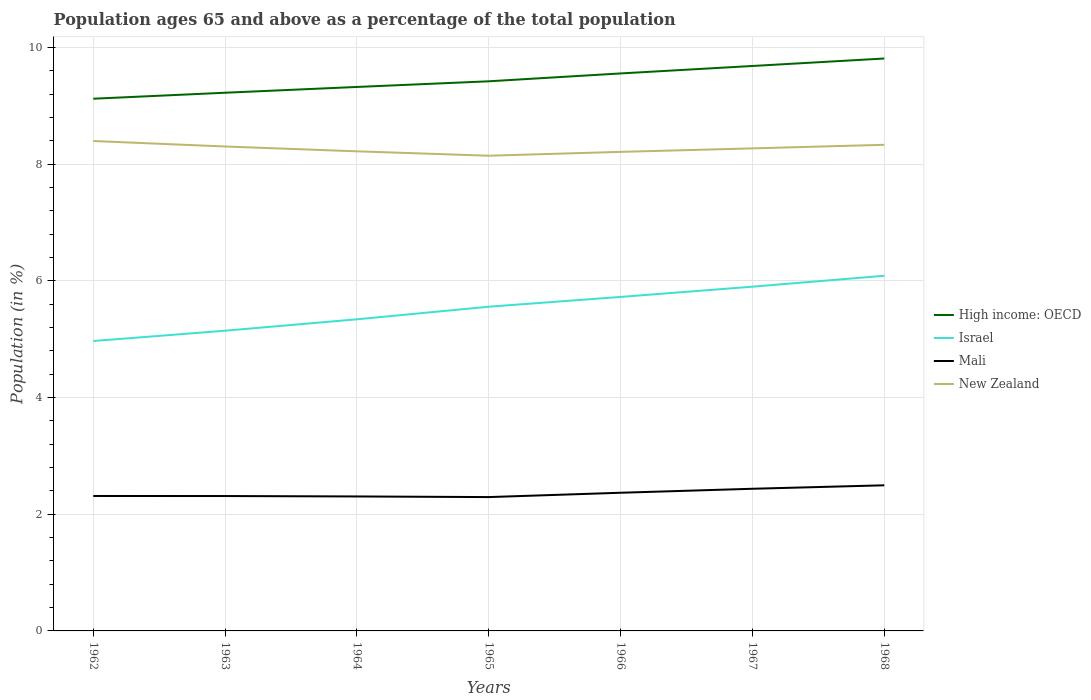Across all years, what is the maximum percentage of the population ages 65 and above in High income: OECD?
Make the answer very short. 9.12. In which year was the percentage of the population ages 65 and above in High income: OECD maximum?
Offer a very short reply. 1962. What is the total percentage of the population ages 65 and above in High income: OECD in the graph?
Keep it short and to the point. -0.36. What is the difference between the highest and the second highest percentage of the population ages 65 and above in Israel?
Your response must be concise. 1.12. Is the percentage of the population ages 65 and above in High income: OECD strictly greater than the percentage of the population ages 65 and above in New Zealand over the years?
Your answer should be very brief. No. How many lines are there?
Offer a very short reply. 4. How many years are there in the graph?
Ensure brevity in your answer.  7. How many legend labels are there?
Offer a very short reply. 4. How are the legend labels stacked?
Your answer should be compact. Vertical. What is the title of the graph?
Offer a very short reply. Population ages 65 and above as a percentage of the total population. Does "Albania" appear as one of the legend labels in the graph?
Your answer should be very brief. No. What is the Population (in %) in High income: OECD in 1962?
Your answer should be very brief. 9.12. What is the Population (in %) in Israel in 1962?
Offer a very short reply. 4.97. What is the Population (in %) of Mali in 1962?
Your answer should be very brief. 2.31. What is the Population (in %) in New Zealand in 1962?
Offer a terse response. 8.4. What is the Population (in %) in High income: OECD in 1963?
Your answer should be compact. 9.22. What is the Population (in %) of Israel in 1963?
Your answer should be compact. 5.14. What is the Population (in %) in Mali in 1963?
Keep it short and to the point. 2.31. What is the Population (in %) in New Zealand in 1963?
Your answer should be very brief. 8.3. What is the Population (in %) of High income: OECD in 1964?
Offer a terse response. 9.32. What is the Population (in %) in Israel in 1964?
Keep it short and to the point. 5.34. What is the Population (in %) of Mali in 1964?
Provide a succinct answer. 2.3. What is the Population (in %) in New Zealand in 1964?
Make the answer very short. 8.22. What is the Population (in %) in High income: OECD in 1965?
Provide a succinct answer. 9.42. What is the Population (in %) in Israel in 1965?
Your response must be concise. 5.56. What is the Population (in %) in Mali in 1965?
Keep it short and to the point. 2.29. What is the Population (in %) of New Zealand in 1965?
Ensure brevity in your answer.  8.14. What is the Population (in %) in High income: OECD in 1966?
Provide a short and direct response. 9.55. What is the Population (in %) in Israel in 1966?
Your answer should be very brief. 5.72. What is the Population (in %) in Mali in 1966?
Provide a succinct answer. 2.37. What is the Population (in %) of New Zealand in 1966?
Provide a succinct answer. 8.21. What is the Population (in %) in High income: OECD in 1967?
Your answer should be compact. 9.68. What is the Population (in %) in Israel in 1967?
Your answer should be very brief. 5.9. What is the Population (in %) of Mali in 1967?
Provide a short and direct response. 2.44. What is the Population (in %) of New Zealand in 1967?
Provide a succinct answer. 8.27. What is the Population (in %) of High income: OECD in 1968?
Give a very brief answer. 9.81. What is the Population (in %) in Israel in 1968?
Your answer should be very brief. 6.09. What is the Population (in %) in Mali in 1968?
Ensure brevity in your answer.  2.5. What is the Population (in %) in New Zealand in 1968?
Your answer should be very brief. 8.33. Across all years, what is the maximum Population (in %) of High income: OECD?
Your answer should be compact. 9.81. Across all years, what is the maximum Population (in %) of Israel?
Provide a short and direct response. 6.09. Across all years, what is the maximum Population (in %) of Mali?
Give a very brief answer. 2.5. Across all years, what is the maximum Population (in %) of New Zealand?
Ensure brevity in your answer.  8.4. Across all years, what is the minimum Population (in %) in High income: OECD?
Ensure brevity in your answer.  9.12. Across all years, what is the minimum Population (in %) of Israel?
Make the answer very short. 4.97. Across all years, what is the minimum Population (in %) in Mali?
Provide a short and direct response. 2.29. Across all years, what is the minimum Population (in %) of New Zealand?
Provide a short and direct response. 8.14. What is the total Population (in %) of High income: OECD in the graph?
Give a very brief answer. 66.13. What is the total Population (in %) in Israel in the graph?
Your answer should be very brief. 38.72. What is the total Population (in %) in Mali in the graph?
Provide a short and direct response. 16.52. What is the total Population (in %) in New Zealand in the graph?
Your answer should be compact. 57.87. What is the difference between the Population (in %) in High income: OECD in 1962 and that in 1963?
Your answer should be compact. -0.1. What is the difference between the Population (in %) of Israel in 1962 and that in 1963?
Keep it short and to the point. -0.18. What is the difference between the Population (in %) in Mali in 1962 and that in 1963?
Your answer should be compact. 0. What is the difference between the Population (in %) in New Zealand in 1962 and that in 1963?
Offer a terse response. 0.09. What is the difference between the Population (in %) in High income: OECD in 1962 and that in 1964?
Your answer should be very brief. -0.2. What is the difference between the Population (in %) in Israel in 1962 and that in 1964?
Your response must be concise. -0.37. What is the difference between the Population (in %) in Mali in 1962 and that in 1964?
Provide a succinct answer. 0.01. What is the difference between the Population (in %) in New Zealand in 1962 and that in 1964?
Your answer should be compact. 0.18. What is the difference between the Population (in %) in High income: OECD in 1962 and that in 1965?
Offer a terse response. -0.3. What is the difference between the Population (in %) of Israel in 1962 and that in 1965?
Ensure brevity in your answer.  -0.59. What is the difference between the Population (in %) in Mali in 1962 and that in 1965?
Provide a short and direct response. 0.02. What is the difference between the Population (in %) in New Zealand in 1962 and that in 1965?
Your answer should be compact. 0.25. What is the difference between the Population (in %) in High income: OECD in 1962 and that in 1966?
Make the answer very short. -0.43. What is the difference between the Population (in %) in Israel in 1962 and that in 1966?
Your answer should be very brief. -0.76. What is the difference between the Population (in %) of Mali in 1962 and that in 1966?
Your answer should be very brief. -0.06. What is the difference between the Population (in %) of New Zealand in 1962 and that in 1966?
Offer a very short reply. 0.19. What is the difference between the Population (in %) of High income: OECD in 1962 and that in 1967?
Ensure brevity in your answer.  -0.56. What is the difference between the Population (in %) in Israel in 1962 and that in 1967?
Your answer should be compact. -0.93. What is the difference between the Population (in %) in Mali in 1962 and that in 1967?
Provide a succinct answer. -0.12. What is the difference between the Population (in %) in New Zealand in 1962 and that in 1967?
Your answer should be compact. 0.13. What is the difference between the Population (in %) of High income: OECD in 1962 and that in 1968?
Provide a short and direct response. -0.69. What is the difference between the Population (in %) in Israel in 1962 and that in 1968?
Your answer should be compact. -1.12. What is the difference between the Population (in %) in Mali in 1962 and that in 1968?
Offer a very short reply. -0.18. What is the difference between the Population (in %) in New Zealand in 1962 and that in 1968?
Keep it short and to the point. 0.06. What is the difference between the Population (in %) of High income: OECD in 1963 and that in 1964?
Provide a short and direct response. -0.1. What is the difference between the Population (in %) of Israel in 1963 and that in 1964?
Ensure brevity in your answer.  -0.2. What is the difference between the Population (in %) of Mali in 1963 and that in 1964?
Your answer should be compact. 0.01. What is the difference between the Population (in %) in New Zealand in 1963 and that in 1964?
Your response must be concise. 0.08. What is the difference between the Population (in %) in High income: OECD in 1963 and that in 1965?
Your answer should be compact. -0.2. What is the difference between the Population (in %) of Israel in 1963 and that in 1965?
Your answer should be compact. -0.41. What is the difference between the Population (in %) in Mali in 1963 and that in 1965?
Make the answer very short. 0.02. What is the difference between the Population (in %) of New Zealand in 1963 and that in 1965?
Give a very brief answer. 0.16. What is the difference between the Population (in %) of High income: OECD in 1963 and that in 1966?
Your response must be concise. -0.33. What is the difference between the Population (in %) in Israel in 1963 and that in 1966?
Your answer should be compact. -0.58. What is the difference between the Population (in %) of Mali in 1963 and that in 1966?
Give a very brief answer. -0.06. What is the difference between the Population (in %) in New Zealand in 1963 and that in 1966?
Offer a terse response. 0.09. What is the difference between the Population (in %) of High income: OECD in 1963 and that in 1967?
Your answer should be very brief. -0.46. What is the difference between the Population (in %) in Israel in 1963 and that in 1967?
Your response must be concise. -0.75. What is the difference between the Population (in %) of Mali in 1963 and that in 1967?
Offer a very short reply. -0.12. What is the difference between the Population (in %) in New Zealand in 1963 and that in 1967?
Make the answer very short. 0.03. What is the difference between the Population (in %) in High income: OECD in 1963 and that in 1968?
Make the answer very short. -0.59. What is the difference between the Population (in %) of Israel in 1963 and that in 1968?
Make the answer very short. -0.94. What is the difference between the Population (in %) of Mali in 1963 and that in 1968?
Your response must be concise. -0.18. What is the difference between the Population (in %) in New Zealand in 1963 and that in 1968?
Your answer should be compact. -0.03. What is the difference between the Population (in %) of High income: OECD in 1964 and that in 1965?
Provide a succinct answer. -0.1. What is the difference between the Population (in %) of Israel in 1964 and that in 1965?
Keep it short and to the point. -0.22. What is the difference between the Population (in %) of Mali in 1964 and that in 1965?
Offer a terse response. 0.01. What is the difference between the Population (in %) in New Zealand in 1964 and that in 1965?
Your answer should be compact. 0.08. What is the difference between the Population (in %) of High income: OECD in 1964 and that in 1966?
Give a very brief answer. -0.23. What is the difference between the Population (in %) of Israel in 1964 and that in 1966?
Offer a very short reply. -0.38. What is the difference between the Population (in %) in Mali in 1964 and that in 1966?
Provide a succinct answer. -0.06. What is the difference between the Population (in %) of New Zealand in 1964 and that in 1966?
Your answer should be compact. 0.01. What is the difference between the Population (in %) in High income: OECD in 1964 and that in 1967?
Provide a short and direct response. -0.36. What is the difference between the Population (in %) of Israel in 1964 and that in 1967?
Offer a very short reply. -0.56. What is the difference between the Population (in %) in Mali in 1964 and that in 1967?
Ensure brevity in your answer.  -0.13. What is the difference between the Population (in %) in New Zealand in 1964 and that in 1967?
Make the answer very short. -0.05. What is the difference between the Population (in %) in High income: OECD in 1964 and that in 1968?
Ensure brevity in your answer.  -0.49. What is the difference between the Population (in %) in Israel in 1964 and that in 1968?
Your answer should be very brief. -0.75. What is the difference between the Population (in %) in Mali in 1964 and that in 1968?
Provide a succinct answer. -0.19. What is the difference between the Population (in %) of New Zealand in 1964 and that in 1968?
Offer a terse response. -0.11. What is the difference between the Population (in %) of High income: OECD in 1965 and that in 1966?
Your response must be concise. -0.13. What is the difference between the Population (in %) of Israel in 1965 and that in 1966?
Make the answer very short. -0.17. What is the difference between the Population (in %) in Mali in 1965 and that in 1966?
Provide a short and direct response. -0.07. What is the difference between the Population (in %) in New Zealand in 1965 and that in 1966?
Give a very brief answer. -0.07. What is the difference between the Population (in %) in High income: OECD in 1965 and that in 1967?
Provide a succinct answer. -0.26. What is the difference between the Population (in %) of Israel in 1965 and that in 1967?
Your answer should be very brief. -0.34. What is the difference between the Population (in %) of Mali in 1965 and that in 1967?
Your answer should be compact. -0.14. What is the difference between the Population (in %) of New Zealand in 1965 and that in 1967?
Your response must be concise. -0.13. What is the difference between the Population (in %) in High income: OECD in 1965 and that in 1968?
Your response must be concise. -0.39. What is the difference between the Population (in %) of Israel in 1965 and that in 1968?
Keep it short and to the point. -0.53. What is the difference between the Population (in %) of Mali in 1965 and that in 1968?
Your response must be concise. -0.2. What is the difference between the Population (in %) in New Zealand in 1965 and that in 1968?
Your answer should be compact. -0.19. What is the difference between the Population (in %) in High income: OECD in 1966 and that in 1967?
Your response must be concise. -0.13. What is the difference between the Population (in %) of Israel in 1966 and that in 1967?
Ensure brevity in your answer.  -0.18. What is the difference between the Population (in %) in Mali in 1966 and that in 1967?
Your response must be concise. -0.07. What is the difference between the Population (in %) in New Zealand in 1966 and that in 1967?
Ensure brevity in your answer.  -0.06. What is the difference between the Population (in %) of High income: OECD in 1966 and that in 1968?
Your answer should be compact. -0.26. What is the difference between the Population (in %) in Israel in 1966 and that in 1968?
Give a very brief answer. -0.36. What is the difference between the Population (in %) of Mali in 1966 and that in 1968?
Your response must be concise. -0.13. What is the difference between the Population (in %) of New Zealand in 1966 and that in 1968?
Your response must be concise. -0.12. What is the difference between the Population (in %) in High income: OECD in 1967 and that in 1968?
Your answer should be compact. -0.13. What is the difference between the Population (in %) of Israel in 1967 and that in 1968?
Keep it short and to the point. -0.19. What is the difference between the Population (in %) in Mali in 1967 and that in 1968?
Keep it short and to the point. -0.06. What is the difference between the Population (in %) in New Zealand in 1967 and that in 1968?
Your answer should be very brief. -0.06. What is the difference between the Population (in %) of High income: OECD in 1962 and the Population (in %) of Israel in 1963?
Your answer should be very brief. 3.98. What is the difference between the Population (in %) of High income: OECD in 1962 and the Population (in %) of Mali in 1963?
Make the answer very short. 6.81. What is the difference between the Population (in %) of High income: OECD in 1962 and the Population (in %) of New Zealand in 1963?
Provide a succinct answer. 0.82. What is the difference between the Population (in %) of Israel in 1962 and the Population (in %) of Mali in 1963?
Offer a terse response. 2.66. What is the difference between the Population (in %) of Israel in 1962 and the Population (in %) of New Zealand in 1963?
Provide a short and direct response. -3.33. What is the difference between the Population (in %) in Mali in 1962 and the Population (in %) in New Zealand in 1963?
Give a very brief answer. -5.99. What is the difference between the Population (in %) of High income: OECD in 1962 and the Population (in %) of Israel in 1964?
Your response must be concise. 3.78. What is the difference between the Population (in %) of High income: OECD in 1962 and the Population (in %) of Mali in 1964?
Offer a very short reply. 6.82. What is the difference between the Population (in %) of High income: OECD in 1962 and the Population (in %) of New Zealand in 1964?
Provide a short and direct response. 0.9. What is the difference between the Population (in %) of Israel in 1962 and the Population (in %) of Mali in 1964?
Give a very brief answer. 2.66. What is the difference between the Population (in %) of Israel in 1962 and the Population (in %) of New Zealand in 1964?
Provide a short and direct response. -3.25. What is the difference between the Population (in %) in Mali in 1962 and the Population (in %) in New Zealand in 1964?
Offer a terse response. -5.91. What is the difference between the Population (in %) of High income: OECD in 1962 and the Population (in %) of Israel in 1965?
Keep it short and to the point. 3.56. What is the difference between the Population (in %) of High income: OECD in 1962 and the Population (in %) of Mali in 1965?
Offer a terse response. 6.83. What is the difference between the Population (in %) in High income: OECD in 1962 and the Population (in %) in New Zealand in 1965?
Your response must be concise. 0.98. What is the difference between the Population (in %) of Israel in 1962 and the Population (in %) of Mali in 1965?
Provide a short and direct response. 2.67. What is the difference between the Population (in %) in Israel in 1962 and the Population (in %) in New Zealand in 1965?
Offer a very short reply. -3.18. What is the difference between the Population (in %) in Mali in 1962 and the Population (in %) in New Zealand in 1965?
Your answer should be compact. -5.83. What is the difference between the Population (in %) in High income: OECD in 1962 and the Population (in %) in Israel in 1966?
Provide a short and direct response. 3.4. What is the difference between the Population (in %) in High income: OECD in 1962 and the Population (in %) in Mali in 1966?
Your answer should be compact. 6.75. What is the difference between the Population (in %) of High income: OECD in 1962 and the Population (in %) of New Zealand in 1966?
Provide a succinct answer. 0.91. What is the difference between the Population (in %) of Israel in 1962 and the Population (in %) of Mali in 1966?
Provide a short and direct response. 2.6. What is the difference between the Population (in %) of Israel in 1962 and the Population (in %) of New Zealand in 1966?
Keep it short and to the point. -3.24. What is the difference between the Population (in %) in Mali in 1962 and the Population (in %) in New Zealand in 1966?
Provide a succinct answer. -5.9. What is the difference between the Population (in %) of High income: OECD in 1962 and the Population (in %) of Israel in 1967?
Provide a succinct answer. 3.22. What is the difference between the Population (in %) in High income: OECD in 1962 and the Population (in %) in Mali in 1967?
Offer a very short reply. 6.68. What is the difference between the Population (in %) in High income: OECD in 1962 and the Population (in %) in New Zealand in 1967?
Give a very brief answer. 0.85. What is the difference between the Population (in %) of Israel in 1962 and the Population (in %) of Mali in 1967?
Your answer should be compact. 2.53. What is the difference between the Population (in %) in Israel in 1962 and the Population (in %) in New Zealand in 1967?
Offer a terse response. -3.3. What is the difference between the Population (in %) of Mali in 1962 and the Population (in %) of New Zealand in 1967?
Keep it short and to the point. -5.96. What is the difference between the Population (in %) of High income: OECD in 1962 and the Population (in %) of Israel in 1968?
Keep it short and to the point. 3.03. What is the difference between the Population (in %) in High income: OECD in 1962 and the Population (in %) in Mali in 1968?
Your answer should be compact. 6.62. What is the difference between the Population (in %) of High income: OECD in 1962 and the Population (in %) of New Zealand in 1968?
Offer a very short reply. 0.79. What is the difference between the Population (in %) of Israel in 1962 and the Population (in %) of Mali in 1968?
Your response must be concise. 2.47. What is the difference between the Population (in %) in Israel in 1962 and the Population (in %) in New Zealand in 1968?
Offer a very short reply. -3.36. What is the difference between the Population (in %) in Mali in 1962 and the Population (in %) in New Zealand in 1968?
Make the answer very short. -6.02. What is the difference between the Population (in %) of High income: OECD in 1963 and the Population (in %) of Israel in 1964?
Make the answer very short. 3.88. What is the difference between the Population (in %) in High income: OECD in 1963 and the Population (in %) in Mali in 1964?
Your answer should be compact. 6.92. What is the difference between the Population (in %) in High income: OECD in 1963 and the Population (in %) in New Zealand in 1964?
Keep it short and to the point. 1. What is the difference between the Population (in %) in Israel in 1963 and the Population (in %) in Mali in 1964?
Keep it short and to the point. 2.84. What is the difference between the Population (in %) in Israel in 1963 and the Population (in %) in New Zealand in 1964?
Your answer should be very brief. -3.07. What is the difference between the Population (in %) of Mali in 1963 and the Population (in %) of New Zealand in 1964?
Keep it short and to the point. -5.91. What is the difference between the Population (in %) in High income: OECD in 1963 and the Population (in %) in Israel in 1965?
Offer a terse response. 3.67. What is the difference between the Population (in %) of High income: OECD in 1963 and the Population (in %) of Mali in 1965?
Your answer should be compact. 6.93. What is the difference between the Population (in %) in High income: OECD in 1963 and the Population (in %) in New Zealand in 1965?
Give a very brief answer. 1.08. What is the difference between the Population (in %) of Israel in 1963 and the Population (in %) of Mali in 1965?
Make the answer very short. 2.85. What is the difference between the Population (in %) in Israel in 1963 and the Population (in %) in New Zealand in 1965?
Your answer should be compact. -3. What is the difference between the Population (in %) of Mali in 1963 and the Population (in %) of New Zealand in 1965?
Ensure brevity in your answer.  -5.83. What is the difference between the Population (in %) of High income: OECD in 1963 and the Population (in %) of Israel in 1966?
Your answer should be compact. 3.5. What is the difference between the Population (in %) in High income: OECD in 1963 and the Population (in %) in Mali in 1966?
Provide a short and direct response. 6.85. What is the difference between the Population (in %) of High income: OECD in 1963 and the Population (in %) of New Zealand in 1966?
Offer a very short reply. 1.01. What is the difference between the Population (in %) of Israel in 1963 and the Population (in %) of Mali in 1966?
Provide a short and direct response. 2.78. What is the difference between the Population (in %) in Israel in 1963 and the Population (in %) in New Zealand in 1966?
Your response must be concise. -3.06. What is the difference between the Population (in %) in Mali in 1963 and the Population (in %) in New Zealand in 1966?
Your answer should be compact. -5.9. What is the difference between the Population (in %) in High income: OECD in 1963 and the Population (in %) in Israel in 1967?
Provide a succinct answer. 3.32. What is the difference between the Population (in %) in High income: OECD in 1963 and the Population (in %) in Mali in 1967?
Provide a short and direct response. 6.79. What is the difference between the Population (in %) in High income: OECD in 1963 and the Population (in %) in New Zealand in 1967?
Make the answer very short. 0.95. What is the difference between the Population (in %) of Israel in 1963 and the Population (in %) of Mali in 1967?
Provide a succinct answer. 2.71. What is the difference between the Population (in %) in Israel in 1963 and the Population (in %) in New Zealand in 1967?
Ensure brevity in your answer.  -3.12. What is the difference between the Population (in %) of Mali in 1963 and the Population (in %) of New Zealand in 1967?
Keep it short and to the point. -5.96. What is the difference between the Population (in %) of High income: OECD in 1963 and the Population (in %) of Israel in 1968?
Ensure brevity in your answer.  3.14. What is the difference between the Population (in %) of High income: OECD in 1963 and the Population (in %) of Mali in 1968?
Provide a succinct answer. 6.73. What is the difference between the Population (in %) in High income: OECD in 1963 and the Population (in %) in New Zealand in 1968?
Provide a short and direct response. 0.89. What is the difference between the Population (in %) in Israel in 1963 and the Population (in %) in Mali in 1968?
Ensure brevity in your answer.  2.65. What is the difference between the Population (in %) in Israel in 1963 and the Population (in %) in New Zealand in 1968?
Offer a terse response. -3.19. What is the difference between the Population (in %) in Mali in 1963 and the Population (in %) in New Zealand in 1968?
Your response must be concise. -6.02. What is the difference between the Population (in %) of High income: OECD in 1964 and the Population (in %) of Israel in 1965?
Your answer should be very brief. 3.77. What is the difference between the Population (in %) of High income: OECD in 1964 and the Population (in %) of Mali in 1965?
Offer a very short reply. 7.03. What is the difference between the Population (in %) in High income: OECD in 1964 and the Population (in %) in New Zealand in 1965?
Give a very brief answer. 1.18. What is the difference between the Population (in %) in Israel in 1964 and the Population (in %) in Mali in 1965?
Your answer should be very brief. 3.05. What is the difference between the Population (in %) of Israel in 1964 and the Population (in %) of New Zealand in 1965?
Provide a succinct answer. -2.8. What is the difference between the Population (in %) of Mali in 1964 and the Population (in %) of New Zealand in 1965?
Keep it short and to the point. -5.84. What is the difference between the Population (in %) of High income: OECD in 1964 and the Population (in %) of Israel in 1966?
Make the answer very short. 3.6. What is the difference between the Population (in %) in High income: OECD in 1964 and the Population (in %) in Mali in 1966?
Provide a succinct answer. 6.95. What is the difference between the Population (in %) of High income: OECD in 1964 and the Population (in %) of New Zealand in 1966?
Keep it short and to the point. 1.11. What is the difference between the Population (in %) in Israel in 1964 and the Population (in %) in Mali in 1966?
Your answer should be compact. 2.97. What is the difference between the Population (in %) in Israel in 1964 and the Population (in %) in New Zealand in 1966?
Your response must be concise. -2.87. What is the difference between the Population (in %) in Mali in 1964 and the Population (in %) in New Zealand in 1966?
Provide a succinct answer. -5.9. What is the difference between the Population (in %) of High income: OECD in 1964 and the Population (in %) of Israel in 1967?
Your response must be concise. 3.42. What is the difference between the Population (in %) in High income: OECD in 1964 and the Population (in %) in Mali in 1967?
Keep it short and to the point. 6.89. What is the difference between the Population (in %) in High income: OECD in 1964 and the Population (in %) in New Zealand in 1967?
Offer a very short reply. 1.05. What is the difference between the Population (in %) of Israel in 1964 and the Population (in %) of Mali in 1967?
Offer a terse response. 2.9. What is the difference between the Population (in %) of Israel in 1964 and the Population (in %) of New Zealand in 1967?
Make the answer very short. -2.93. What is the difference between the Population (in %) of Mali in 1964 and the Population (in %) of New Zealand in 1967?
Offer a very short reply. -5.96. What is the difference between the Population (in %) in High income: OECD in 1964 and the Population (in %) in Israel in 1968?
Offer a terse response. 3.24. What is the difference between the Population (in %) in High income: OECD in 1964 and the Population (in %) in Mali in 1968?
Keep it short and to the point. 6.83. What is the difference between the Population (in %) in High income: OECD in 1964 and the Population (in %) in New Zealand in 1968?
Make the answer very short. 0.99. What is the difference between the Population (in %) of Israel in 1964 and the Population (in %) of Mali in 1968?
Offer a very short reply. 2.84. What is the difference between the Population (in %) in Israel in 1964 and the Population (in %) in New Zealand in 1968?
Make the answer very short. -2.99. What is the difference between the Population (in %) of Mali in 1964 and the Population (in %) of New Zealand in 1968?
Your response must be concise. -6.03. What is the difference between the Population (in %) of High income: OECD in 1965 and the Population (in %) of Israel in 1966?
Your answer should be compact. 3.69. What is the difference between the Population (in %) in High income: OECD in 1965 and the Population (in %) in Mali in 1966?
Keep it short and to the point. 7.05. What is the difference between the Population (in %) of High income: OECD in 1965 and the Population (in %) of New Zealand in 1966?
Ensure brevity in your answer.  1.21. What is the difference between the Population (in %) in Israel in 1965 and the Population (in %) in Mali in 1966?
Offer a terse response. 3.19. What is the difference between the Population (in %) of Israel in 1965 and the Population (in %) of New Zealand in 1966?
Provide a short and direct response. -2.65. What is the difference between the Population (in %) of Mali in 1965 and the Population (in %) of New Zealand in 1966?
Offer a terse response. -5.92. What is the difference between the Population (in %) of High income: OECD in 1965 and the Population (in %) of Israel in 1967?
Offer a very short reply. 3.52. What is the difference between the Population (in %) in High income: OECD in 1965 and the Population (in %) in Mali in 1967?
Your answer should be compact. 6.98. What is the difference between the Population (in %) in High income: OECD in 1965 and the Population (in %) in New Zealand in 1967?
Your response must be concise. 1.15. What is the difference between the Population (in %) of Israel in 1965 and the Population (in %) of Mali in 1967?
Provide a succinct answer. 3.12. What is the difference between the Population (in %) in Israel in 1965 and the Population (in %) in New Zealand in 1967?
Offer a very short reply. -2.71. What is the difference between the Population (in %) of Mali in 1965 and the Population (in %) of New Zealand in 1967?
Your answer should be very brief. -5.98. What is the difference between the Population (in %) of High income: OECD in 1965 and the Population (in %) of Israel in 1968?
Make the answer very short. 3.33. What is the difference between the Population (in %) of High income: OECD in 1965 and the Population (in %) of Mali in 1968?
Offer a very short reply. 6.92. What is the difference between the Population (in %) in High income: OECD in 1965 and the Population (in %) in New Zealand in 1968?
Provide a short and direct response. 1.09. What is the difference between the Population (in %) in Israel in 1965 and the Population (in %) in Mali in 1968?
Provide a succinct answer. 3.06. What is the difference between the Population (in %) of Israel in 1965 and the Population (in %) of New Zealand in 1968?
Keep it short and to the point. -2.77. What is the difference between the Population (in %) of Mali in 1965 and the Population (in %) of New Zealand in 1968?
Your answer should be compact. -6.04. What is the difference between the Population (in %) in High income: OECD in 1966 and the Population (in %) in Israel in 1967?
Provide a short and direct response. 3.65. What is the difference between the Population (in %) of High income: OECD in 1966 and the Population (in %) of Mali in 1967?
Provide a succinct answer. 7.12. What is the difference between the Population (in %) of High income: OECD in 1966 and the Population (in %) of New Zealand in 1967?
Offer a very short reply. 1.28. What is the difference between the Population (in %) in Israel in 1966 and the Population (in %) in Mali in 1967?
Offer a very short reply. 3.29. What is the difference between the Population (in %) of Israel in 1966 and the Population (in %) of New Zealand in 1967?
Your answer should be very brief. -2.55. What is the difference between the Population (in %) in Mali in 1966 and the Population (in %) in New Zealand in 1967?
Your answer should be very brief. -5.9. What is the difference between the Population (in %) of High income: OECD in 1966 and the Population (in %) of Israel in 1968?
Give a very brief answer. 3.47. What is the difference between the Population (in %) in High income: OECD in 1966 and the Population (in %) in Mali in 1968?
Ensure brevity in your answer.  7.06. What is the difference between the Population (in %) of High income: OECD in 1966 and the Population (in %) of New Zealand in 1968?
Your answer should be compact. 1.22. What is the difference between the Population (in %) in Israel in 1966 and the Population (in %) in Mali in 1968?
Keep it short and to the point. 3.23. What is the difference between the Population (in %) of Israel in 1966 and the Population (in %) of New Zealand in 1968?
Provide a succinct answer. -2.61. What is the difference between the Population (in %) in Mali in 1966 and the Population (in %) in New Zealand in 1968?
Offer a very short reply. -5.96. What is the difference between the Population (in %) of High income: OECD in 1967 and the Population (in %) of Israel in 1968?
Ensure brevity in your answer.  3.6. What is the difference between the Population (in %) of High income: OECD in 1967 and the Population (in %) of Mali in 1968?
Provide a short and direct response. 7.19. What is the difference between the Population (in %) of High income: OECD in 1967 and the Population (in %) of New Zealand in 1968?
Make the answer very short. 1.35. What is the difference between the Population (in %) in Israel in 1967 and the Population (in %) in Mali in 1968?
Give a very brief answer. 3.4. What is the difference between the Population (in %) of Israel in 1967 and the Population (in %) of New Zealand in 1968?
Give a very brief answer. -2.43. What is the difference between the Population (in %) in Mali in 1967 and the Population (in %) in New Zealand in 1968?
Provide a succinct answer. -5.89. What is the average Population (in %) of High income: OECD per year?
Provide a succinct answer. 9.45. What is the average Population (in %) in Israel per year?
Offer a very short reply. 5.53. What is the average Population (in %) in Mali per year?
Provide a short and direct response. 2.36. What is the average Population (in %) in New Zealand per year?
Provide a short and direct response. 8.27. In the year 1962, what is the difference between the Population (in %) in High income: OECD and Population (in %) in Israel?
Ensure brevity in your answer.  4.15. In the year 1962, what is the difference between the Population (in %) in High income: OECD and Population (in %) in Mali?
Ensure brevity in your answer.  6.81. In the year 1962, what is the difference between the Population (in %) in High income: OECD and Population (in %) in New Zealand?
Your answer should be very brief. 0.72. In the year 1962, what is the difference between the Population (in %) in Israel and Population (in %) in Mali?
Give a very brief answer. 2.66. In the year 1962, what is the difference between the Population (in %) in Israel and Population (in %) in New Zealand?
Give a very brief answer. -3.43. In the year 1962, what is the difference between the Population (in %) of Mali and Population (in %) of New Zealand?
Ensure brevity in your answer.  -6.08. In the year 1963, what is the difference between the Population (in %) in High income: OECD and Population (in %) in Israel?
Your answer should be compact. 4.08. In the year 1963, what is the difference between the Population (in %) of High income: OECD and Population (in %) of Mali?
Provide a succinct answer. 6.91. In the year 1963, what is the difference between the Population (in %) in High income: OECD and Population (in %) in New Zealand?
Offer a terse response. 0.92. In the year 1963, what is the difference between the Population (in %) in Israel and Population (in %) in Mali?
Make the answer very short. 2.83. In the year 1963, what is the difference between the Population (in %) of Israel and Population (in %) of New Zealand?
Give a very brief answer. -3.16. In the year 1963, what is the difference between the Population (in %) in Mali and Population (in %) in New Zealand?
Keep it short and to the point. -5.99. In the year 1964, what is the difference between the Population (in %) in High income: OECD and Population (in %) in Israel?
Your answer should be compact. 3.98. In the year 1964, what is the difference between the Population (in %) of High income: OECD and Population (in %) of Mali?
Offer a terse response. 7.02. In the year 1964, what is the difference between the Population (in %) in High income: OECD and Population (in %) in New Zealand?
Give a very brief answer. 1.1. In the year 1964, what is the difference between the Population (in %) in Israel and Population (in %) in Mali?
Offer a terse response. 3.04. In the year 1964, what is the difference between the Population (in %) of Israel and Population (in %) of New Zealand?
Make the answer very short. -2.88. In the year 1964, what is the difference between the Population (in %) in Mali and Population (in %) in New Zealand?
Your answer should be compact. -5.91. In the year 1965, what is the difference between the Population (in %) in High income: OECD and Population (in %) in Israel?
Offer a terse response. 3.86. In the year 1965, what is the difference between the Population (in %) of High income: OECD and Population (in %) of Mali?
Your response must be concise. 7.12. In the year 1965, what is the difference between the Population (in %) of High income: OECD and Population (in %) of New Zealand?
Give a very brief answer. 1.28. In the year 1965, what is the difference between the Population (in %) in Israel and Population (in %) in Mali?
Your answer should be compact. 3.26. In the year 1965, what is the difference between the Population (in %) in Israel and Population (in %) in New Zealand?
Provide a short and direct response. -2.59. In the year 1965, what is the difference between the Population (in %) in Mali and Population (in %) in New Zealand?
Ensure brevity in your answer.  -5.85. In the year 1966, what is the difference between the Population (in %) in High income: OECD and Population (in %) in Israel?
Offer a terse response. 3.83. In the year 1966, what is the difference between the Population (in %) in High income: OECD and Population (in %) in Mali?
Ensure brevity in your answer.  7.19. In the year 1966, what is the difference between the Population (in %) of High income: OECD and Population (in %) of New Zealand?
Your response must be concise. 1.34. In the year 1966, what is the difference between the Population (in %) in Israel and Population (in %) in Mali?
Your answer should be compact. 3.36. In the year 1966, what is the difference between the Population (in %) of Israel and Population (in %) of New Zealand?
Provide a short and direct response. -2.49. In the year 1966, what is the difference between the Population (in %) in Mali and Population (in %) in New Zealand?
Give a very brief answer. -5.84. In the year 1967, what is the difference between the Population (in %) in High income: OECD and Population (in %) in Israel?
Your answer should be compact. 3.78. In the year 1967, what is the difference between the Population (in %) of High income: OECD and Population (in %) of Mali?
Your answer should be very brief. 7.25. In the year 1967, what is the difference between the Population (in %) in High income: OECD and Population (in %) in New Zealand?
Ensure brevity in your answer.  1.41. In the year 1967, what is the difference between the Population (in %) in Israel and Population (in %) in Mali?
Offer a very short reply. 3.46. In the year 1967, what is the difference between the Population (in %) in Israel and Population (in %) in New Zealand?
Your response must be concise. -2.37. In the year 1967, what is the difference between the Population (in %) of Mali and Population (in %) of New Zealand?
Give a very brief answer. -5.83. In the year 1968, what is the difference between the Population (in %) of High income: OECD and Population (in %) of Israel?
Offer a terse response. 3.72. In the year 1968, what is the difference between the Population (in %) of High income: OECD and Population (in %) of Mali?
Ensure brevity in your answer.  7.31. In the year 1968, what is the difference between the Population (in %) in High income: OECD and Population (in %) in New Zealand?
Provide a succinct answer. 1.48. In the year 1968, what is the difference between the Population (in %) of Israel and Population (in %) of Mali?
Your answer should be very brief. 3.59. In the year 1968, what is the difference between the Population (in %) of Israel and Population (in %) of New Zealand?
Provide a short and direct response. -2.24. In the year 1968, what is the difference between the Population (in %) in Mali and Population (in %) in New Zealand?
Give a very brief answer. -5.83. What is the ratio of the Population (in %) of High income: OECD in 1962 to that in 1963?
Your response must be concise. 0.99. What is the ratio of the Population (in %) of Israel in 1962 to that in 1963?
Provide a succinct answer. 0.97. What is the ratio of the Population (in %) in Mali in 1962 to that in 1963?
Provide a succinct answer. 1. What is the ratio of the Population (in %) of New Zealand in 1962 to that in 1963?
Ensure brevity in your answer.  1.01. What is the ratio of the Population (in %) of High income: OECD in 1962 to that in 1964?
Offer a terse response. 0.98. What is the ratio of the Population (in %) of Israel in 1962 to that in 1964?
Keep it short and to the point. 0.93. What is the ratio of the Population (in %) in New Zealand in 1962 to that in 1964?
Your response must be concise. 1.02. What is the ratio of the Population (in %) of High income: OECD in 1962 to that in 1965?
Offer a terse response. 0.97. What is the ratio of the Population (in %) of Israel in 1962 to that in 1965?
Provide a succinct answer. 0.89. What is the ratio of the Population (in %) of Mali in 1962 to that in 1965?
Make the answer very short. 1.01. What is the ratio of the Population (in %) of New Zealand in 1962 to that in 1965?
Your answer should be very brief. 1.03. What is the ratio of the Population (in %) of High income: OECD in 1962 to that in 1966?
Your answer should be compact. 0.95. What is the ratio of the Population (in %) in Israel in 1962 to that in 1966?
Make the answer very short. 0.87. What is the ratio of the Population (in %) of Mali in 1962 to that in 1966?
Provide a short and direct response. 0.98. What is the ratio of the Population (in %) of New Zealand in 1962 to that in 1966?
Your response must be concise. 1.02. What is the ratio of the Population (in %) in High income: OECD in 1962 to that in 1967?
Ensure brevity in your answer.  0.94. What is the ratio of the Population (in %) of Israel in 1962 to that in 1967?
Offer a very short reply. 0.84. What is the ratio of the Population (in %) of Mali in 1962 to that in 1967?
Your answer should be compact. 0.95. What is the ratio of the Population (in %) of New Zealand in 1962 to that in 1967?
Give a very brief answer. 1.02. What is the ratio of the Population (in %) in High income: OECD in 1962 to that in 1968?
Make the answer very short. 0.93. What is the ratio of the Population (in %) of Israel in 1962 to that in 1968?
Provide a short and direct response. 0.82. What is the ratio of the Population (in %) in Mali in 1962 to that in 1968?
Your response must be concise. 0.93. What is the ratio of the Population (in %) of Israel in 1963 to that in 1964?
Ensure brevity in your answer.  0.96. What is the ratio of the Population (in %) of New Zealand in 1963 to that in 1964?
Your response must be concise. 1.01. What is the ratio of the Population (in %) of High income: OECD in 1963 to that in 1965?
Your answer should be compact. 0.98. What is the ratio of the Population (in %) in Israel in 1963 to that in 1965?
Provide a short and direct response. 0.93. What is the ratio of the Population (in %) in New Zealand in 1963 to that in 1965?
Give a very brief answer. 1.02. What is the ratio of the Population (in %) of High income: OECD in 1963 to that in 1966?
Your answer should be compact. 0.97. What is the ratio of the Population (in %) of Israel in 1963 to that in 1966?
Offer a terse response. 0.9. What is the ratio of the Population (in %) of Mali in 1963 to that in 1966?
Your answer should be very brief. 0.98. What is the ratio of the Population (in %) in New Zealand in 1963 to that in 1966?
Give a very brief answer. 1.01. What is the ratio of the Population (in %) of High income: OECD in 1963 to that in 1967?
Ensure brevity in your answer.  0.95. What is the ratio of the Population (in %) of Israel in 1963 to that in 1967?
Keep it short and to the point. 0.87. What is the ratio of the Population (in %) in Mali in 1963 to that in 1967?
Give a very brief answer. 0.95. What is the ratio of the Population (in %) in High income: OECD in 1963 to that in 1968?
Offer a very short reply. 0.94. What is the ratio of the Population (in %) of Israel in 1963 to that in 1968?
Ensure brevity in your answer.  0.85. What is the ratio of the Population (in %) in Mali in 1963 to that in 1968?
Make the answer very short. 0.93. What is the ratio of the Population (in %) in High income: OECD in 1964 to that in 1965?
Your answer should be very brief. 0.99. What is the ratio of the Population (in %) in Israel in 1964 to that in 1965?
Provide a short and direct response. 0.96. What is the ratio of the Population (in %) of Mali in 1964 to that in 1965?
Offer a terse response. 1. What is the ratio of the Population (in %) of New Zealand in 1964 to that in 1965?
Make the answer very short. 1.01. What is the ratio of the Population (in %) of High income: OECD in 1964 to that in 1966?
Ensure brevity in your answer.  0.98. What is the ratio of the Population (in %) in Israel in 1964 to that in 1966?
Your answer should be very brief. 0.93. What is the ratio of the Population (in %) of Mali in 1964 to that in 1966?
Your answer should be compact. 0.97. What is the ratio of the Population (in %) of New Zealand in 1964 to that in 1966?
Keep it short and to the point. 1. What is the ratio of the Population (in %) in High income: OECD in 1964 to that in 1967?
Provide a succinct answer. 0.96. What is the ratio of the Population (in %) of Israel in 1964 to that in 1967?
Keep it short and to the point. 0.91. What is the ratio of the Population (in %) of Mali in 1964 to that in 1967?
Give a very brief answer. 0.95. What is the ratio of the Population (in %) in High income: OECD in 1964 to that in 1968?
Your answer should be very brief. 0.95. What is the ratio of the Population (in %) in Israel in 1964 to that in 1968?
Ensure brevity in your answer.  0.88. What is the ratio of the Population (in %) of Mali in 1964 to that in 1968?
Your answer should be compact. 0.92. What is the ratio of the Population (in %) in New Zealand in 1964 to that in 1968?
Your answer should be compact. 0.99. What is the ratio of the Population (in %) of High income: OECD in 1965 to that in 1966?
Provide a short and direct response. 0.99. What is the ratio of the Population (in %) of Israel in 1965 to that in 1966?
Give a very brief answer. 0.97. What is the ratio of the Population (in %) of Mali in 1965 to that in 1966?
Provide a succinct answer. 0.97. What is the ratio of the Population (in %) of High income: OECD in 1965 to that in 1967?
Make the answer very short. 0.97. What is the ratio of the Population (in %) of Israel in 1965 to that in 1967?
Make the answer very short. 0.94. What is the ratio of the Population (in %) in Mali in 1965 to that in 1967?
Ensure brevity in your answer.  0.94. What is the ratio of the Population (in %) of High income: OECD in 1965 to that in 1968?
Give a very brief answer. 0.96. What is the ratio of the Population (in %) of Israel in 1965 to that in 1968?
Your answer should be compact. 0.91. What is the ratio of the Population (in %) of Mali in 1965 to that in 1968?
Offer a terse response. 0.92. What is the ratio of the Population (in %) of New Zealand in 1965 to that in 1968?
Ensure brevity in your answer.  0.98. What is the ratio of the Population (in %) of Israel in 1966 to that in 1967?
Offer a terse response. 0.97. What is the ratio of the Population (in %) of Mali in 1966 to that in 1967?
Provide a short and direct response. 0.97. What is the ratio of the Population (in %) of New Zealand in 1966 to that in 1967?
Offer a terse response. 0.99. What is the ratio of the Population (in %) of High income: OECD in 1966 to that in 1968?
Your answer should be compact. 0.97. What is the ratio of the Population (in %) of Israel in 1966 to that in 1968?
Your answer should be compact. 0.94. What is the ratio of the Population (in %) in Mali in 1966 to that in 1968?
Provide a succinct answer. 0.95. What is the ratio of the Population (in %) of New Zealand in 1966 to that in 1968?
Offer a terse response. 0.99. What is the ratio of the Population (in %) in High income: OECD in 1967 to that in 1968?
Your answer should be compact. 0.99. What is the ratio of the Population (in %) in Israel in 1967 to that in 1968?
Offer a terse response. 0.97. What is the ratio of the Population (in %) in Mali in 1967 to that in 1968?
Make the answer very short. 0.98. What is the difference between the highest and the second highest Population (in %) in High income: OECD?
Your response must be concise. 0.13. What is the difference between the highest and the second highest Population (in %) of Israel?
Give a very brief answer. 0.19. What is the difference between the highest and the second highest Population (in %) of Mali?
Your response must be concise. 0.06. What is the difference between the highest and the second highest Population (in %) in New Zealand?
Your answer should be compact. 0.06. What is the difference between the highest and the lowest Population (in %) in High income: OECD?
Provide a short and direct response. 0.69. What is the difference between the highest and the lowest Population (in %) in Israel?
Make the answer very short. 1.12. What is the difference between the highest and the lowest Population (in %) in Mali?
Offer a very short reply. 0.2. What is the difference between the highest and the lowest Population (in %) of New Zealand?
Your answer should be compact. 0.25. 